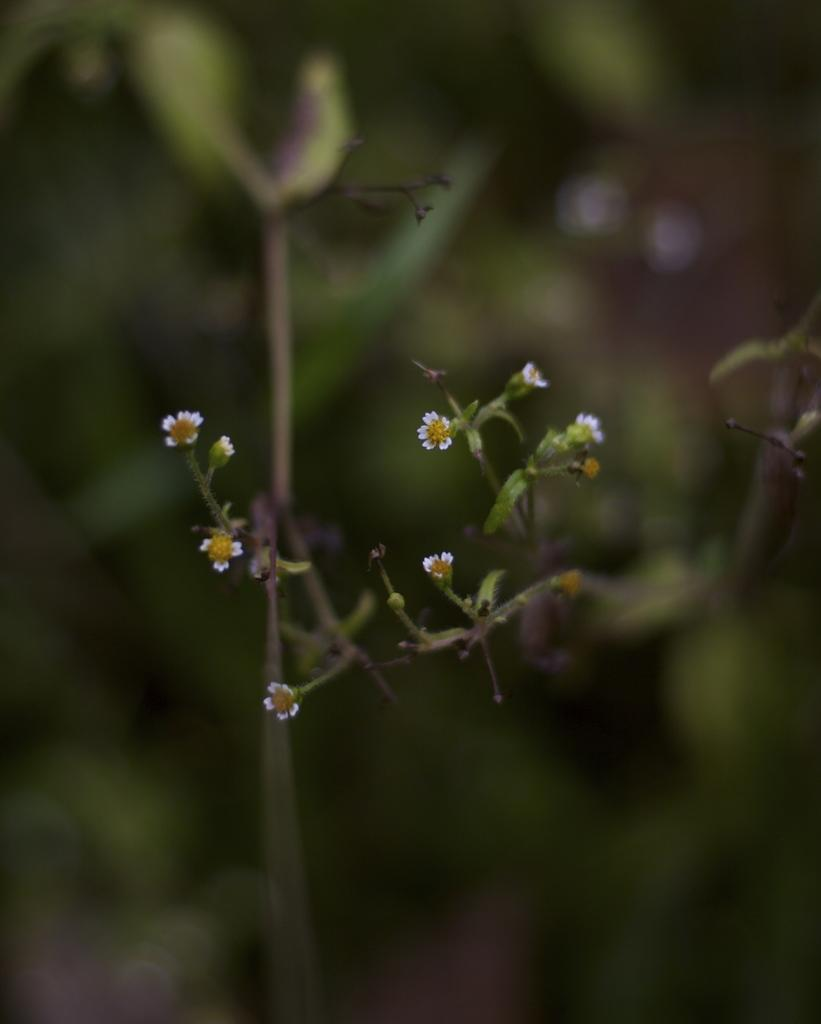What types of living organisms can be seen in the image? Plants and flowers are visible in the image. Can you describe the flowers in the image? The flowers in the image are part of the plants and add color and beauty to the scene. How many trucks are parked next to the plants in the image? There are no trucks present in the image; it only features plants and flowers. 